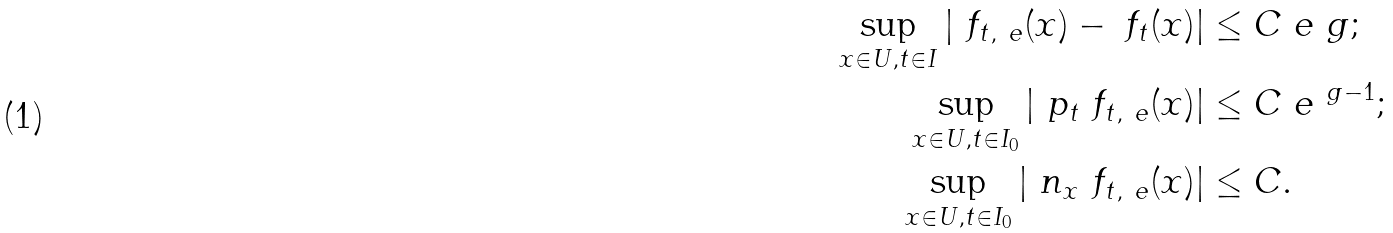<formula> <loc_0><loc_0><loc_500><loc_500>\sup _ { x \in U , t \in I } | \ f _ { t , \ e } ( x ) - \ f _ { t } ( x ) | & \leq C \ e ^ { \ } g ; \\ \sup _ { x \in U , t \in I _ { 0 } } | \ p _ { t } \ f _ { t , \ e } ( x ) | & \leq C \ e ^ { \ g - 1 } ; \\ \sup _ { x \in U , t \in I _ { 0 } } | \ n _ { x } \ f _ { t , \ e } ( x ) | & \leq C .</formula> 